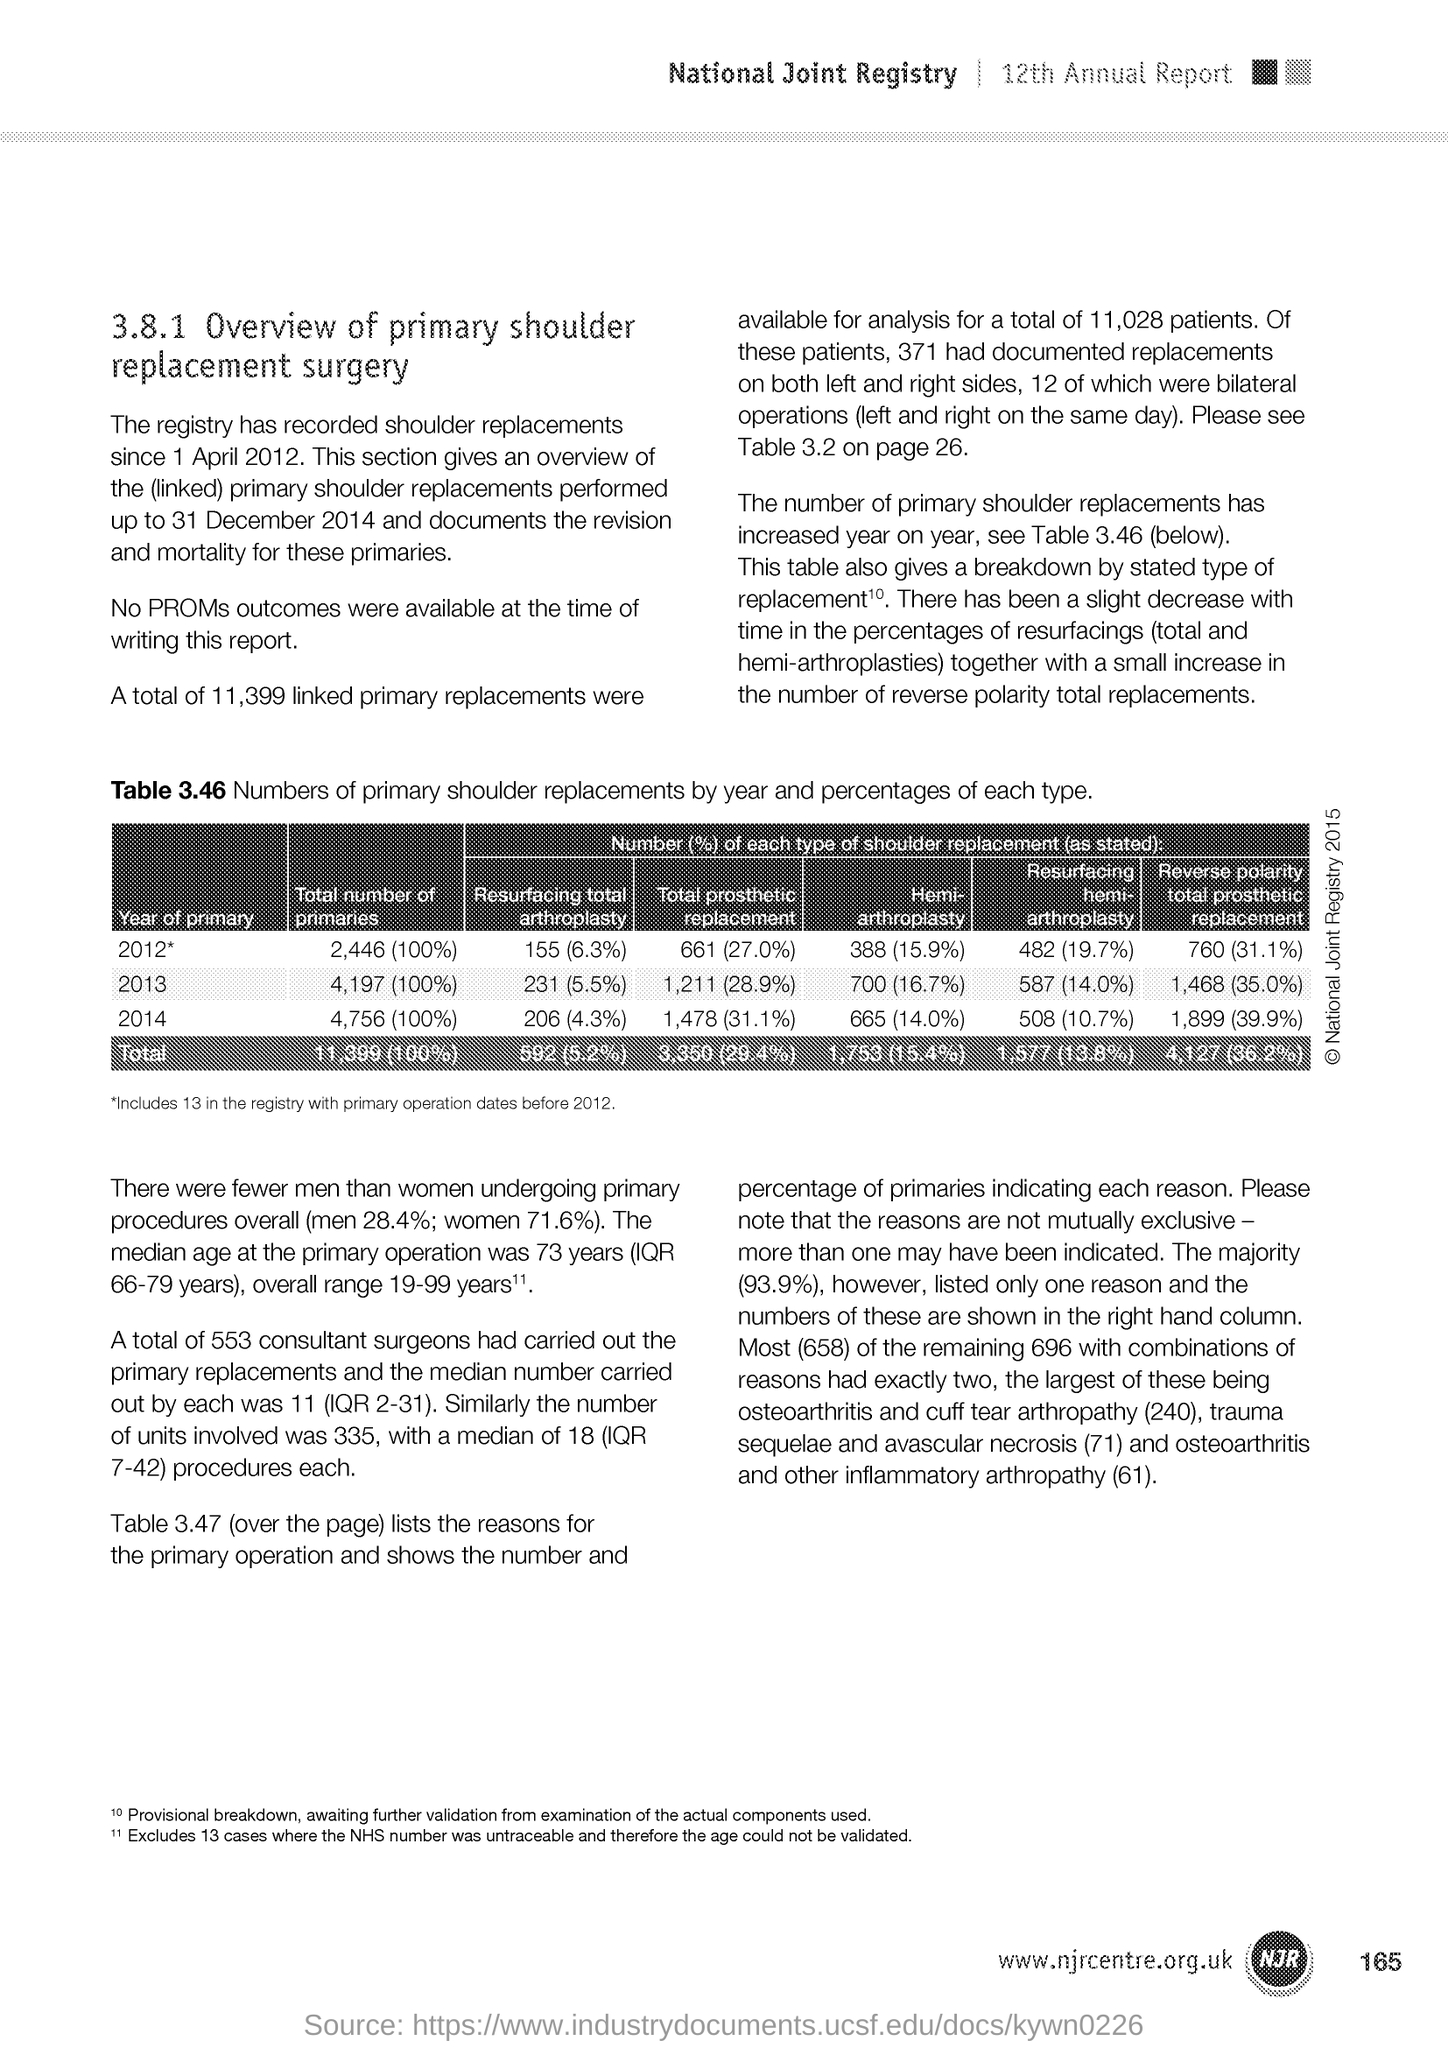Which edition of Annual Report is mentioned in the document?
Make the answer very short. 12th. 